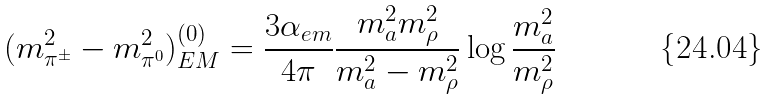<formula> <loc_0><loc_0><loc_500><loc_500>( m _ { \pi ^ { \pm } } ^ { 2 } - m _ { \pi ^ { 0 } } ^ { 2 } ) _ { E M } ^ { ( 0 ) } = \frac { 3 \alpha _ { e m } } { 4 \pi } \frac { m _ { a } ^ { 2 } m _ { \rho } ^ { 2 } } { m _ { a } ^ { 2 } - m _ { \rho } ^ { 2 } } \log { \frac { m _ { a } ^ { 2 } } { m _ { \rho } ^ { 2 } } }</formula> 